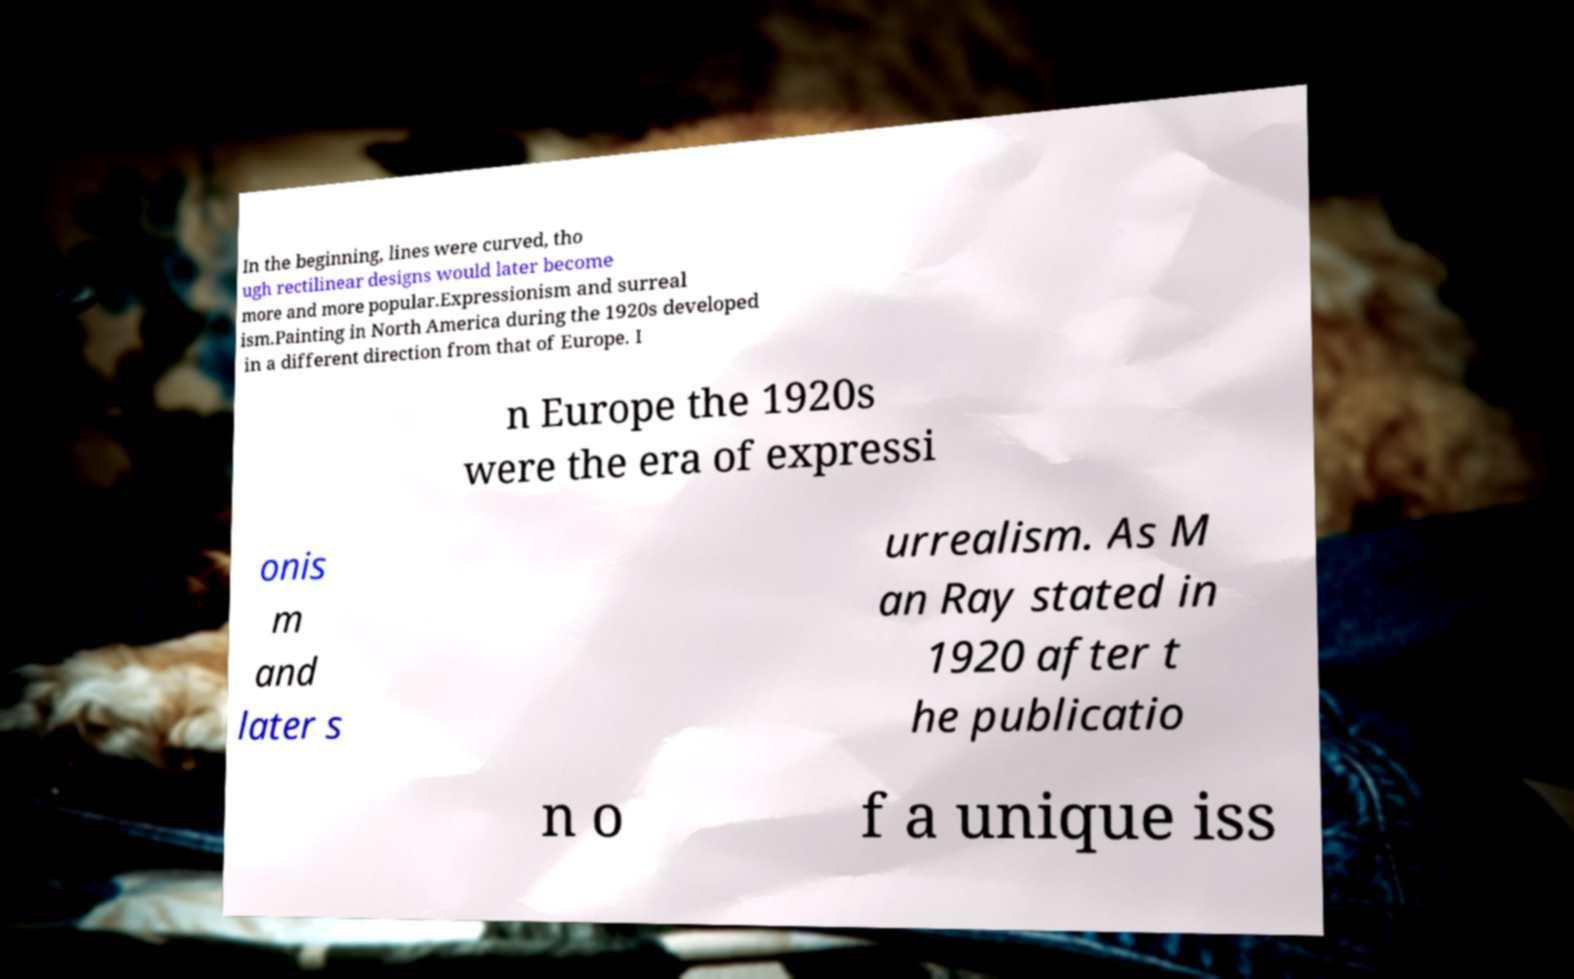Can you accurately transcribe the text from the provided image for me? In the beginning, lines were curved, tho ugh rectilinear designs would later become more and more popular.Expressionism and surreal ism.Painting in North America during the 1920s developed in a different direction from that of Europe. I n Europe the 1920s were the era of expressi onis m and later s urrealism. As M an Ray stated in 1920 after t he publicatio n o f a unique iss 